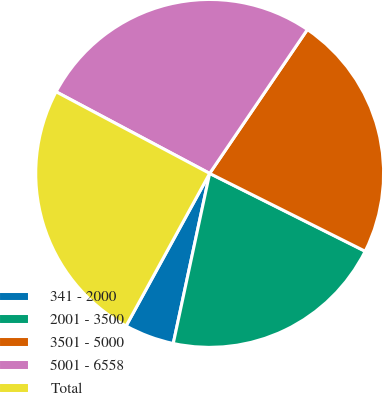<chart> <loc_0><loc_0><loc_500><loc_500><pie_chart><fcel>341 - 2000<fcel>2001 - 3500<fcel>3501 - 5000<fcel>5001 - 6558<fcel>Total<nl><fcel>4.62%<fcel>20.97%<fcel>22.89%<fcel>26.72%<fcel>24.8%<nl></chart> 